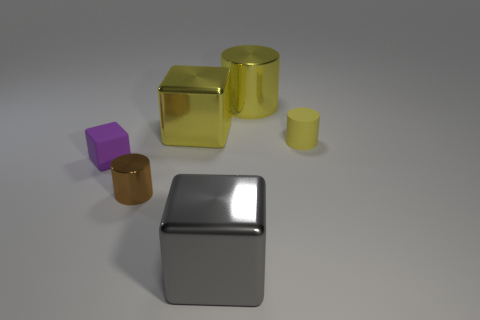Add 2 large gray matte cubes. How many objects exist? 8 Subtract all small shiny objects. Subtract all brown objects. How many objects are left? 4 Add 4 large metallic cylinders. How many large metallic cylinders are left? 5 Add 1 small brown shiny objects. How many small brown shiny objects exist? 2 Subtract 0 red cylinders. How many objects are left? 6 